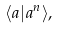<formula> <loc_0><loc_0><loc_500><loc_500>\langle a | a ^ { n } \rangle ,</formula> 